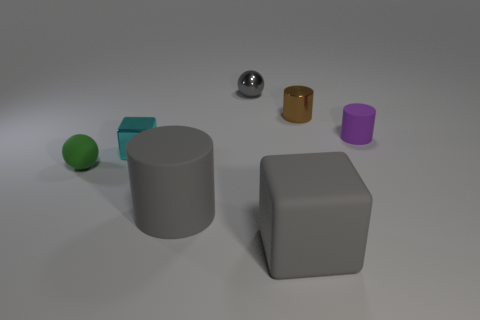What shape is the big object that is the same color as the big cylinder?
Ensure brevity in your answer.  Cube. There is a rubber cylinder that is in front of the purple rubber object; how big is it?
Give a very brief answer. Large. There is a large matte object in front of the large matte thing that is to the left of the gray rubber cube; what is its color?
Offer a terse response. Gray. Is the number of tiny gray balls that are to the right of the large gray matte cube greater than the number of tiny shiny balls that are on the right side of the tiny rubber ball?
Your answer should be compact. No. Are the cube that is in front of the tiny green matte thing and the cylinder in front of the small green ball made of the same material?
Offer a terse response. Yes. Are there any spheres to the right of the small green object?
Give a very brief answer. Yes. What number of cyan things are small rubber cylinders or big objects?
Offer a terse response. 0. Is the tiny gray thing made of the same material as the block that is in front of the shiny block?
Keep it short and to the point. No. There is a brown metal object that is the same shape as the tiny purple matte thing; what size is it?
Offer a terse response. Small. What is the purple object made of?
Keep it short and to the point. Rubber. 